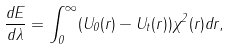<formula> <loc_0><loc_0><loc_500><loc_500>\frac { d E } { d \lambda } = \int _ { 0 } ^ { \infty } ( U _ { 0 } ( r ) - U _ { t } ( r ) ) \chi ^ { 2 } ( r ) d r ,</formula> 